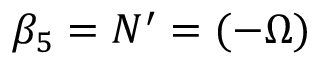<formula> <loc_0><loc_0><loc_500><loc_500>\beta _ { 5 } = N ^ { \prime } = ( - \Omega )</formula> 